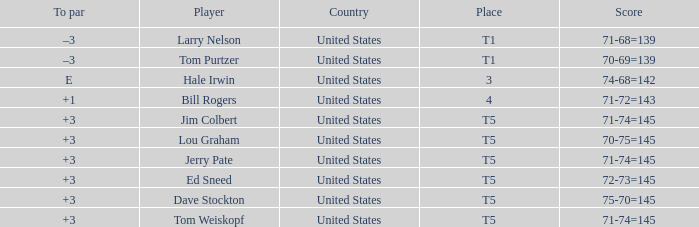Give me the full table as a dictionary. {'header': ['To par', 'Player', 'Country', 'Place', 'Score'], 'rows': [['–3', 'Larry Nelson', 'United States', 'T1', '71-68=139'], ['–3', 'Tom Purtzer', 'United States', 'T1', '70-69=139'], ['E', 'Hale Irwin', 'United States', '3', '74-68=142'], ['+1', 'Bill Rogers', 'United States', '4', '71-72=143'], ['+3', 'Jim Colbert', 'United States', 'T5', '71-74=145'], ['+3', 'Lou Graham', 'United States', 'T5', '70-75=145'], ['+3', 'Jerry Pate', 'United States', 'T5', '71-74=145'], ['+3', 'Ed Sneed', 'United States', 'T5', '72-73=145'], ['+3', 'Dave Stockton', 'United States', 'T5', '75-70=145'], ['+3', 'Tom Weiskopf', 'United States', 'T5', '71-74=145']]} Who is the player with a t5 place and a 75-70=145 score? Dave Stockton. 